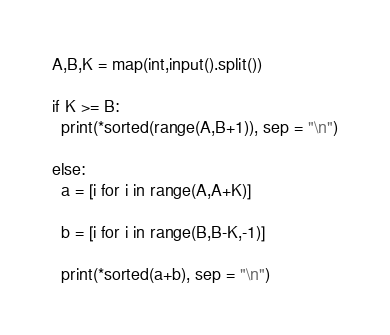<code> <loc_0><loc_0><loc_500><loc_500><_Python_>A,B,K = map(int,input().split())

if K >= B:
  print(*sorted(range(A,B+1)), sep = "\n")

else:
  a = [i for i in range(A,A+K)]

  b = [i for i in range(B,B-K,-1)]

  print(*sorted(a+b), sep = "\n")</code> 